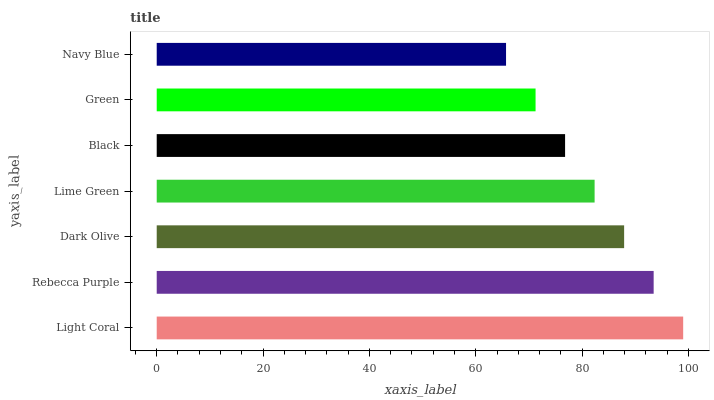Is Navy Blue the minimum?
Answer yes or no. Yes. Is Light Coral the maximum?
Answer yes or no. Yes. Is Rebecca Purple the minimum?
Answer yes or no. No. Is Rebecca Purple the maximum?
Answer yes or no. No. Is Light Coral greater than Rebecca Purple?
Answer yes or no. Yes. Is Rebecca Purple less than Light Coral?
Answer yes or no. Yes. Is Rebecca Purple greater than Light Coral?
Answer yes or no. No. Is Light Coral less than Rebecca Purple?
Answer yes or no. No. Is Lime Green the high median?
Answer yes or no. Yes. Is Lime Green the low median?
Answer yes or no. Yes. Is Dark Olive the high median?
Answer yes or no. No. Is Navy Blue the low median?
Answer yes or no. No. 